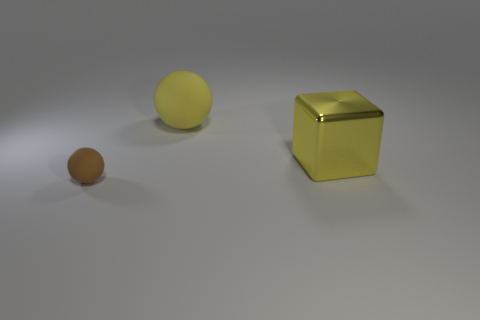Add 1 small purple matte balls. How many objects exist? 4 Subtract all spheres. How many objects are left? 1 Add 3 cyan shiny cylinders. How many cyan shiny cylinders exist? 3 Subtract 0 purple spheres. How many objects are left? 3 Subtract all large rubber balls. Subtract all yellow rubber spheres. How many objects are left? 1 Add 1 large yellow blocks. How many large yellow blocks are left? 2 